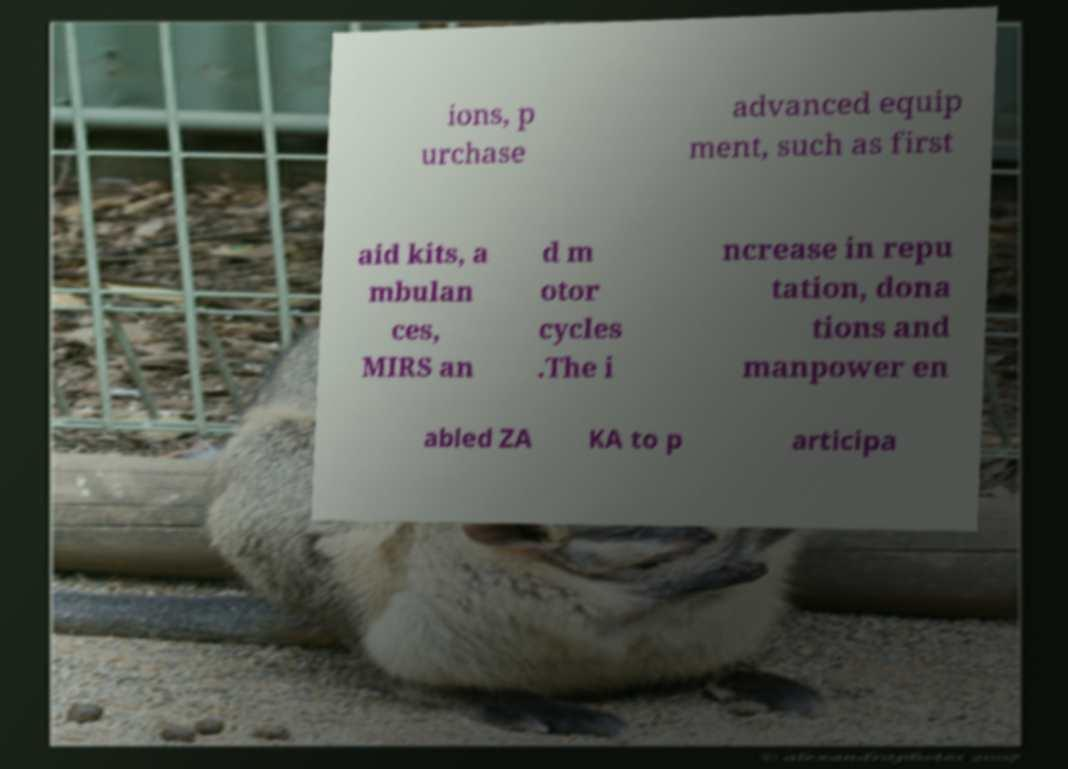Could you extract and type out the text from this image? ions, p urchase advanced equip ment, such as first aid kits, a mbulan ces, MIRS an d m otor cycles .The i ncrease in repu tation, dona tions and manpower en abled ZA KA to p articipa 